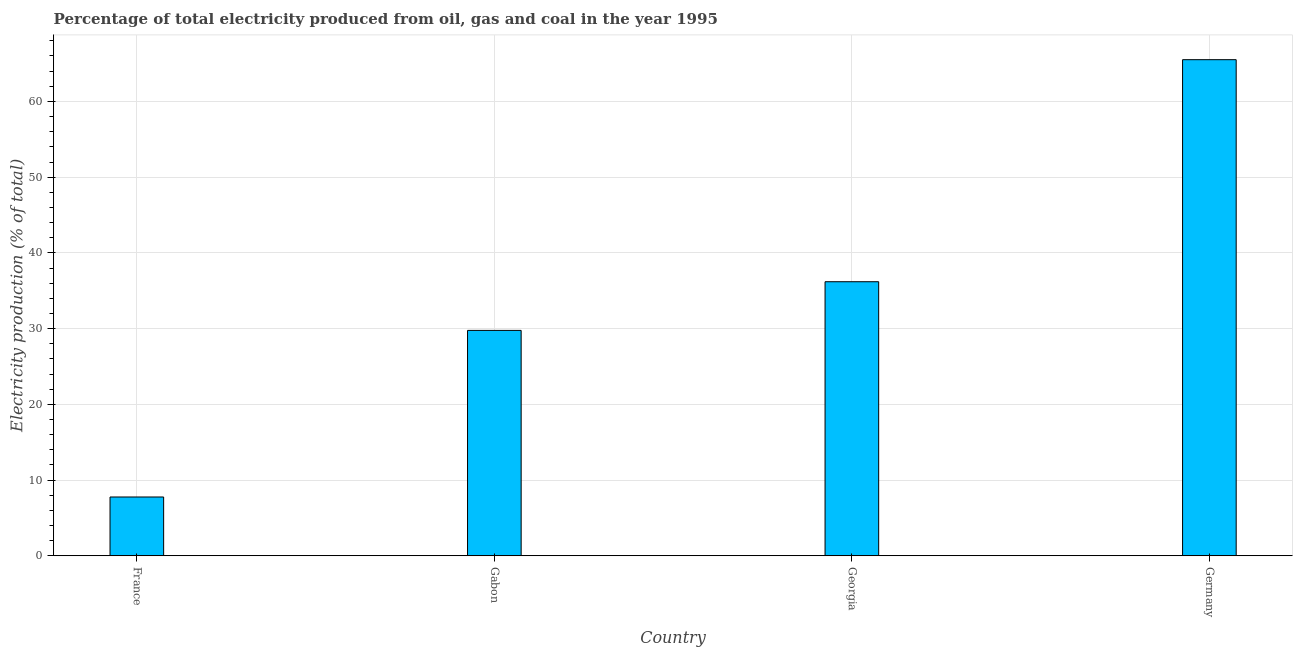Does the graph contain grids?
Give a very brief answer. Yes. What is the title of the graph?
Give a very brief answer. Percentage of total electricity produced from oil, gas and coal in the year 1995. What is the label or title of the X-axis?
Your response must be concise. Country. What is the label or title of the Y-axis?
Your answer should be compact. Electricity production (% of total). What is the electricity production in Germany?
Give a very brief answer. 65.51. Across all countries, what is the maximum electricity production?
Your answer should be very brief. 65.51. Across all countries, what is the minimum electricity production?
Your answer should be compact. 7.77. In which country was the electricity production minimum?
Your response must be concise. France. What is the sum of the electricity production?
Offer a terse response. 139.23. What is the difference between the electricity production in Gabon and Georgia?
Offer a terse response. -6.43. What is the average electricity production per country?
Your answer should be very brief. 34.81. What is the median electricity production?
Make the answer very short. 32.98. In how many countries, is the electricity production greater than 16 %?
Your response must be concise. 3. What is the ratio of the electricity production in Gabon to that in Germany?
Your answer should be compact. 0.45. Is the electricity production in France less than that in Germany?
Give a very brief answer. Yes. Is the difference between the electricity production in France and Germany greater than the difference between any two countries?
Make the answer very short. Yes. What is the difference between the highest and the second highest electricity production?
Ensure brevity in your answer.  29.32. Is the sum of the electricity production in France and Georgia greater than the maximum electricity production across all countries?
Provide a short and direct response. No. What is the difference between the highest and the lowest electricity production?
Your answer should be compact. 57.75. In how many countries, is the electricity production greater than the average electricity production taken over all countries?
Keep it short and to the point. 2. How many bars are there?
Make the answer very short. 4. Are the values on the major ticks of Y-axis written in scientific E-notation?
Give a very brief answer. No. What is the Electricity production (% of total) in France?
Offer a very short reply. 7.77. What is the Electricity production (% of total) in Gabon?
Keep it short and to the point. 29.76. What is the Electricity production (% of total) in Georgia?
Provide a succinct answer. 36.19. What is the Electricity production (% of total) of Germany?
Your response must be concise. 65.51. What is the difference between the Electricity production (% of total) in France and Gabon?
Your answer should be compact. -22. What is the difference between the Electricity production (% of total) in France and Georgia?
Your answer should be compact. -28.43. What is the difference between the Electricity production (% of total) in France and Germany?
Provide a succinct answer. -57.75. What is the difference between the Electricity production (% of total) in Gabon and Georgia?
Keep it short and to the point. -6.43. What is the difference between the Electricity production (% of total) in Gabon and Germany?
Ensure brevity in your answer.  -35.75. What is the difference between the Electricity production (% of total) in Georgia and Germany?
Give a very brief answer. -29.32. What is the ratio of the Electricity production (% of total) in France to that in Gabon?
Keep it short and to the point. 0.26. What is the ratio of the Electricity production (% of total) in France to that in Georgia?
Your response must be concise. 0.21. What is the ratio of the Electricity production (% of total) in France to that in Germany?
Ensure brevity in your answer.  0.12. What is the ratio of the Electricity production (% of total) in Gabon to that in Georgia?
Your response must be concise. 0.82. What is the ratio of the Electricity production (% of total) in Gabon to that in Germany?
Give a very brief answer. 0.45. What is the ratio of the Electricity production (% of total) in Georgia to that in Germany?
Your answer should be compact. 0.55. 